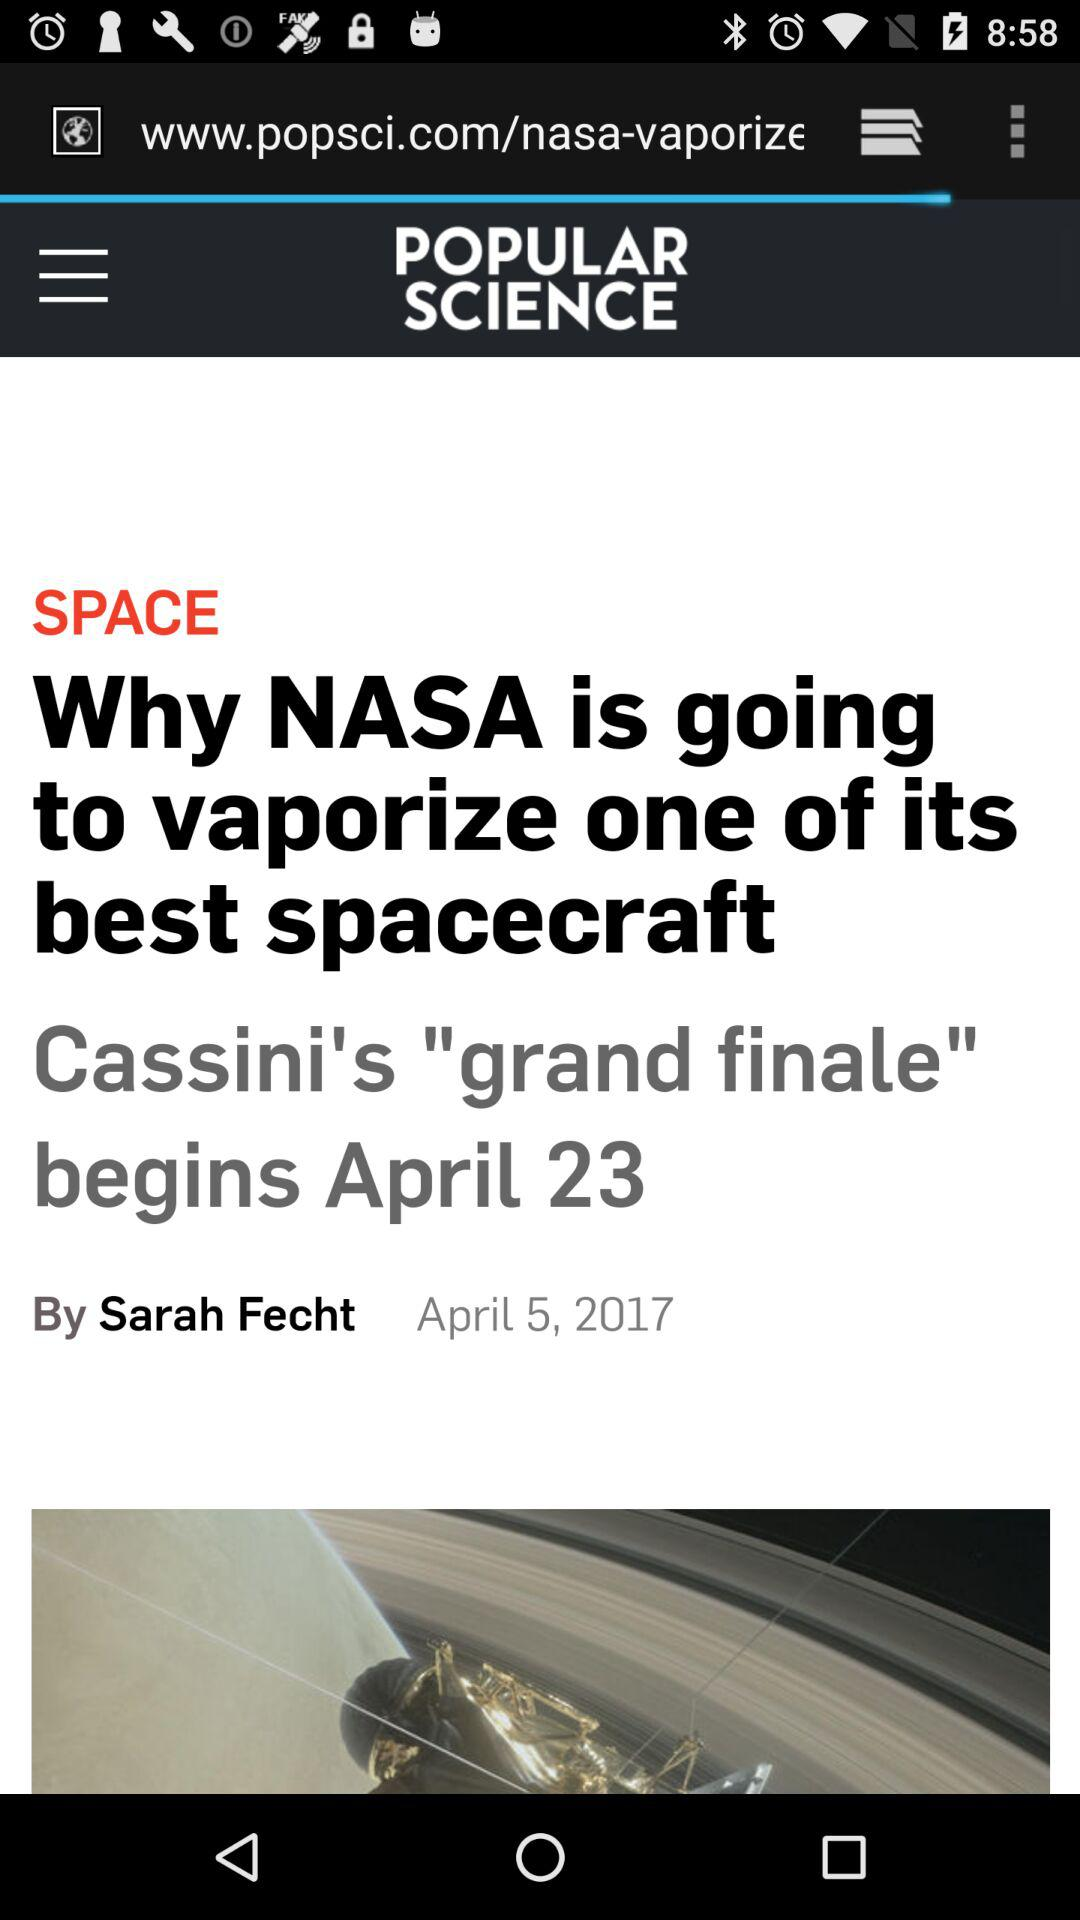Who is the author of the article? The author is Sarah Fecht. 